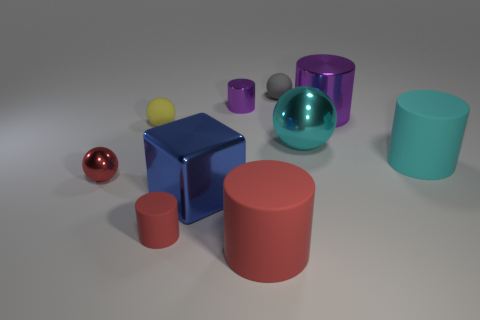How does the lighting in this scene affect the appearance of the objects? The lighting creates soft shadows that give the objects depth and help distinguish their forms. The reflective surfaces capture highlights and mirror the environment, adding to the realistic appearance of the materials. Could you infer the position of the light source based on the shadows and highlights? Yes, based on the direction and length of the shadows and the placement of the highlights on the objects, it appears that the primary light source is coming from the upper left side of the scene. 